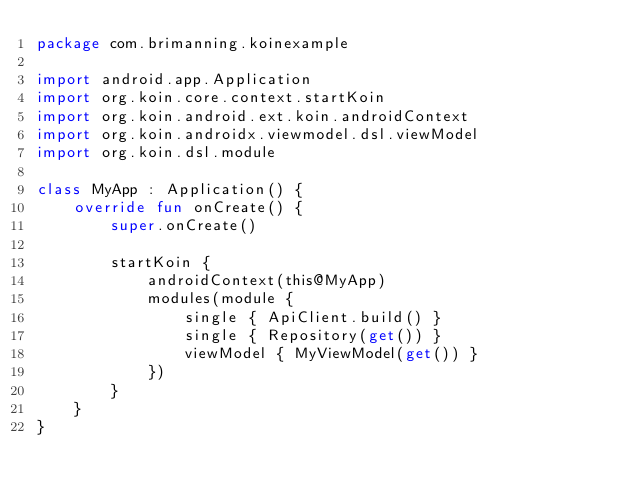<code> <loc_0><loc_0><loc_500><loc_500><_Kotlin_>package com.brimanning.koinexample

import android.app.Application
import org.koin.core.context.startKoin
import org.koin.android.ext.koin.androidContext
import org.koin.androidx.viewmodel.dsl.viewModel
import org.koin.dsl.module

class MyApp : Application() {
    override fun onCreate() {
        super.onCreate()

        startKoin {
            androidContext(this@MyApp)
            modules(module {
                single { ApiClient.build() }
                single { Repository(get()) }
                viewModel { MyViewModel(get()) }
            })
        }
    }
}</code> 